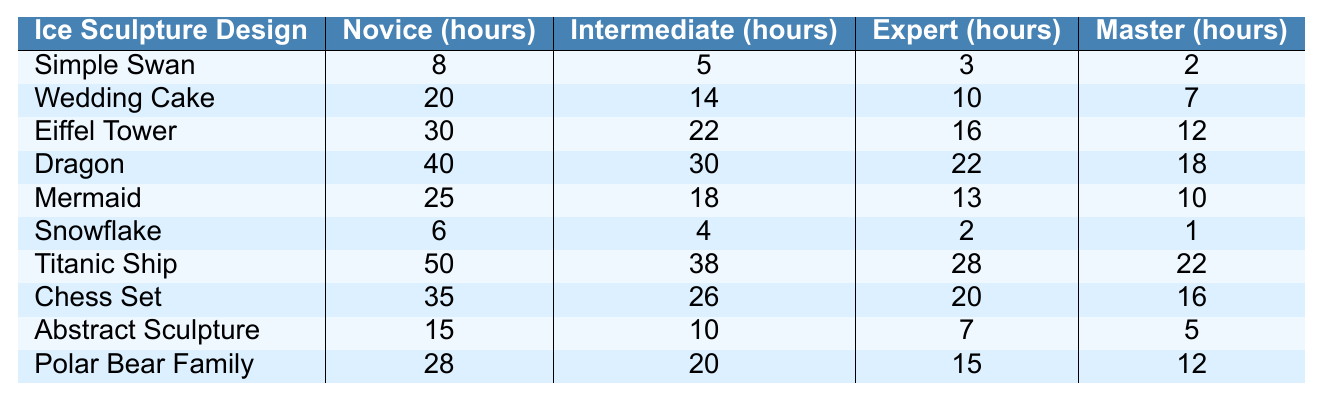What is the time required for an Expert to create a Simple Swan? According to the table, the time required for an Expert to create a Simple Swan is listed under the "Expert (hours)" column. The value there is 3 hours.
Answer: 3 hours What is the total time required for a Novice to create a Wedding Cake and a Dragon? The time required for a Novice to create a Wedding Cake is 20 hours and for a Dragon is 40 hours. Summing these gives 20 + 40 = 60 hours.
Answer: 60 hours Is it faster for a Master to create a Snowflake or a Polar Bear Family? Looking at the "Master (hours)" column, the time for a Snowflake is 1 hour and for a Polar Bear Family is 12 hours. Since 1 hour is less than 12 hours, it is faster to create a Snowflake.
Answer: Yes Which ice sculpture design takes the longest time for an Intermediate? In the "Intermediate (hours)" column, the longest time is 38 hours for the Titanic Ship. This is the highest value in that column.
Answer: Titanic Ship What is the difference in hours between the time required for an Expert to create a Dragon and a Mermaid? From the table, an Expert takes 22 hours for a Dragon and 13 hours for a Mermaid. The difference is calculated as 22 - 13 = 9 hours.
Answer: 9 hours If a Master can create three designs, how many total hours would it take for a Simple Swan, a Snowflake, and an Abstract Sculpture? The time for a Simple Swan is 2 hours, for a Snowflake is 1 hour, and for an Abstract Sculpture is 5 hours. Adding these gives 2 + 1 + 5 = 8 hours.
Answer: 8 hours Is the time required for a Novice to make an Abstract Sculpture less than the time required for an Expert to make an Eiffel Tower? The time for a Novice to make an Abstract Sculpture is 15 hours, and the time for an Expert to make an Eiffel Tower is 16 hours. Since 15 is less than 16, the Novice's time is indeed less.
Answer: Yes What is the average time required for a Master to create the five most complex ice sculptures: Dragon, Titanic Ship, Chess Set, Eiffel Tower, and Wedding Cake? The times for a Master to create these designs are 18, 22, 16, 12, and 7 hours, respectively. Summing these gives 18 + 22 + 16 + 12 + 7 = 75 hours. The average is 75 hours divided by 5, which equals 15 hours.
Answer: 15 hours 